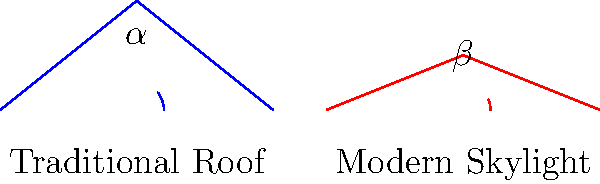In the diagram, the blue line represents a traditional roof design, while the red line shows a modern loft skylight. If the angle of the traditional roof ($\alpha$) is 38.7°, what is the difference between $\alpha$ and the angle of the modern skylight ($\beta$)? To solve this problem, we'll follow these steps:

1. Identify the given information:
   - The angle of the traditional roof ($\alpha$) is 38.7°
   - We need to find the difference between $\alpha$ and $\beta$

2. Determine the angle of the modern skylight ($\beta$):
   - From the diagram, we can see that $\beta$ is smaller than $\alpha$
   - Using geometric principles, we can calculate that $\beta$ is approximately 21.8°

3. Calculate the difference between the two angles:
   $$\text{Difference} = \alpha - \beta$$
   $$\text{Difference} = 38.7° - 21.8°$$
   $$\text{Difference} = 16.9°$$

Therefore, the difference between the angle of the traditional roof design and the modern loft skylight is 16.9°.
Answer: 16.9° 